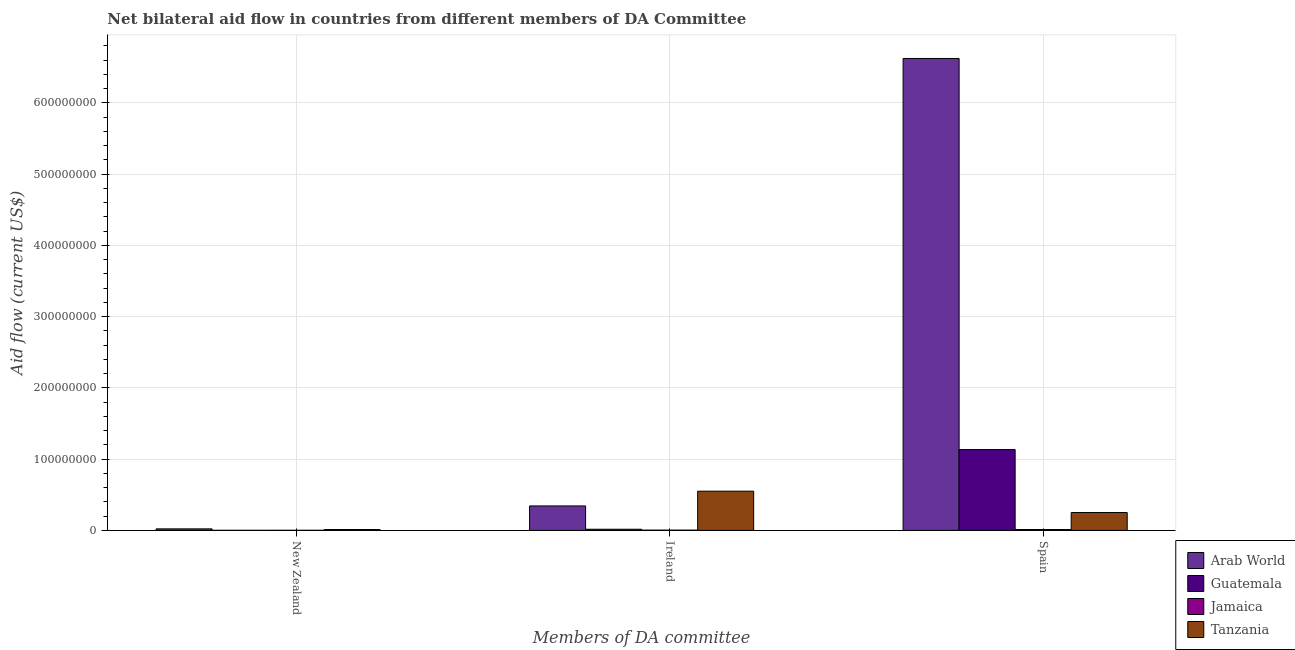Are the number of bars on each tick of the X-axis equal?
Provide a succinct answer. Yes. What is the label of the 1st group of bars from the left?
Keep it short and to the point. New Zealand. What is the amount of aid provided by ireland in Jamaica?
Provide a short and direct response. 3.50e+05. Across all countries, what is the maximum amount of aid provided by spain?
Your answer should be very brief. 6.62e+08. Across all countries, what is the minimum amount of aid provided by new zealand?
Ensure brevity in your answer.  8.00e+04. In which country was the amount of aid provided by new zealand maximum?
Your response must be concise. Arab World. In which country was the amount of aid provided by new zealand minimum?
Your answer should be compact. Guatemala. What is the total amount of aid provided by new zealand in the graph?
Your answer should be very brief. 3.55e+06. What is the difference between the amount of aid provided by ireland in Guatemala and that in Tanzania?
Give a very brief answer. -5.34e+07. What is the difference between the amount of aid provided by new zealand in Tanzania and the amount of aid provided by ireland in Guatemala?
Provide a succinct answer. -3.90e+05. What is the average amount of aid provided by spain per country?
Ensure brevity in your answer.  2.00e+08. What is the difference between the amount of aid provided by ireland and amount of aid provided by spain in Arab World?
Keep it short and to the point. -6.28e+08. In how many countries, is the amount of aid provided by ireland greater than 240000000 US$?
Your answer should be very brief. 0. What is the ratio of the amount of aid provided by spain in Arab World to that in Guatemala?
Provide a succinct answer. 5.84. What is the difference between the highest and the second highest amount of aid provided by spain?
Provide a succinct answer. 5.49e+08. What is the difference between the highest and the lowest amount of aid provided by ireland?
Your answer should be very brief. 5.47e+07. What does the 4th bar from the left in Spain represents?
Offer a terse response. Tanzania. What does the 4th bar from the right in Spain represents?
Your response must be concise. Arab World. How many bars are there?
Keep it short and to the point. 12. Are all the bars in the graph horizontal?
Ensure brevity in your answer.  No. How many countries are there in the graph?
Offer a terse response. 4. Are the values on the major ticks of Y-axis written in scientific E-notation?
Provide a succinct answer. No. Does the graph contain any zero values?
Offer a very short reply. No. Does the graph contain grids?
Your answer should be very brief. Yes. Where does the legend appear in the graph?
Your response must be concise. Bottom right. How many legend labels are there?
Your response must be concise. 4. What is the title of the graph?
Keep it short and to the point. Net bilateral aid flow in countries from different members of DA Committee. What is the label or title of the X-axis?
Ensure brevity in your answer.  Members of DA committee. What is the label or title of the Y-axis?
Your answer should be very brief. Aid flow (current US$). What is the Aid flow (current US$) of Arab World in New Zealand?
Make the answer very short. 2.14e+06. What is the Aid flow (current US$) in Guatemala in New Zealand?
Offer a very short reply. 8.00e+04. What is the Aid flow (current US$) in Tanzania in New Zealand?
Provide a short and direct response. 1.22e+06. What is the Aid flow (current US$) of Arab World in Ireland?
Ensure brevity in your answer.  3.43e+07. What is the Aid flow (current US$) of Guatemala in Ireland?
Provide a succinct answer. 1.61e+06. What is the Aid flow (current US$) in Tanzania in Ireland?
Offer a very short reply. 5.50e+07. What is the Aid flow (current US$) of Arab World in Spain?
Give a very brief answer. 6.62e+08. What is the Aid flow (current US$) of Guatemala in Spain?
Offer a terse response. 1.13e+08. What is the Aid flow (current US$) of Jamaica in Spain?
Ensure brevity in your answer.  1.19e+06. What is the Aid flow (current US$) of Tanzania in Spain?
Ensure brevity in your answer.  2.51e+07. Across all Members of DA committee, what is the maximum Aid flow (current US$) in Arab World?
Your answer should be compact. 6.62e+08. Across all Members of DA committee, what is the maximum Aid flow (current US$) in Guatemala?
Your answer should be very brief. 1.13e+08. Across all Members of DA committee, what is the maximum Aid flow (current US$) of Jamaica?
Your answer should be compact. 1.19e+06. Across all Members of DA committee, what is the maximum Aid flow (current US$) of Tanzania?
Make the answer very short. 5.50e+07. Across all Members of DA committee, what is the minimum Aid flow (current US$) in Arab World?
Give a very brief answer. 2.14e+06. Across all Members of DA committee, what is the minimum Aid flow (current US$) of Tanzania?
Offer a terse response. 1.22e+06. What is the total Aid flow (current US$) in Arab World in the graph?
Your response must be concise. 6.99e+08. What is the total Aid flow (current US$) of Guatemala in the graph?
Your response must be concise. 1.15e+08. What is the total Aid flow (current US$) in Jamaica in the graph?
Your answer should be compact. 1.65e+06. What is the total Aid flow (current US$) of Tanzania in the graph?
Provide a short and direct response. 8.13e+07. What is the difference between the Aid flow (current US$) of Arab World in New Zealand and that in Ireland?
Your answer should be compact. -3.22e+07. What is the difference between the Aid flow (current US$) in Guatemala in New Zealand and that in Ireland?
Your response must be concise. -1.53e+06. What is the difference between the Aid flow (current US$) of Jamaica in New Zealand and that in Ireland?
Keep it short and to the point. -2.40e+05. What is the difference between the Aid flow (current US$) of Tanzania in New Zealand and that in Ireland?
Provide a succinct answer. -5.38e+07. What is the difference between the Aid flow (current US$) of Arab World in New Zealand and that in Spain?
Keep it short and to the point. -6.60e+08. What is the difference between the Aid flow (current US$) in Guatemala in New Zealand and that in Spain?
Give a very brief answer. -1.13e+08. What is the difference between the Aid flow (current US$) in Jamaica in New Zealand and that in Spain?
Provide a short and direct response. -1.08e+06. What is the difference between the Aid flow (current US$) of Tanzania in New Zealand and that in Spain?
Offer a terse response. -2.39e+07. What is the difference between the Aid flow (current US$) in Arab World in Ireland and that in Spain?
Give a very brief answer. -6.28e+08. What is the difference between the Aid flow (current US$) in Guatemala in Ireland and that in Spain?
Make the answer very short. -1.12e+08. What is the difference between the Aid flow (current US$) in Jamaica in Ireland and that in Spain?
Your answer should be compact. -8.40e+05. What is the difference between the Aid flow (current US$) in Tanzania in Ireland and that in Spain?
Your answer should be compact. 3.00e+07. What is the difference between the Aid flow (current US$) in Arab World in New Zealand and the Aid flow (current US$) in Guatemala in Ireland?
Offer a terse response. 5.30e+05. What is the difference between the Aid flow (current US$) in Arab World in New Zealand and the Aid flow (current US$) in Jamaica in Ireland?
Your answer should be compact. 1.79e+06. What is the difference between the Aid flow (current US$) in Arab World in New Zealand and the Aid flow (current US$) in Tanzania in Ireland?
Ensure brevity in your answer.  -5.29e+07. What is the difference between the Aid flow (current US$) of Guatemala in New Zealand and the Aid flow (current US$) of Jamaica in Ireland?
Give a very brief answer. -2.70e+05. What is the difference between the Aid flow (current US$) in Guatemala in New Zealand and the Aid flow (current US$) in Tanzania in Ireland?
Offer a terse response. -5.50e+07. What is the difference between the Aid flow (current US$) in Jamaica in New Zealand and the Aid flow (current US$) in Tanzania in Ireland?
Your response must be concise. -5.49e+07. What is the difference between the Aid flow (current US$) in Arab World in New Zealand and the Aid flow (current US$) in Guatemala in Spain?
Your answer should be very brief. -1.11e+08. What is the difference between the Aid flow (current US$) in Arab World in New Zealand and the Aid flow (current US$) in Jamaica in Spain?
Your response must be concise. 9.50e+05. What is the difference between the Aid flow (current US$) in Arab World in New Zealand and the Aid flow (current US$) in Tanzania in Spain?
Ensure brevity in your answer.  -2.29e+07. What is the difference between the Aid flow (current US$) of Guatemala in New Zealand and the Aid flow (current US$) of Jamaica in Spain?
Your answer should be very brief. -1.11e+06. What is the difference between the Aid flow (current US$) in Guatemala in New Zealand and the Aid flow (current US$) in Tanzania in Spain?
Your answer should be very brief. -2.50e+07. What is the difference between the Aid flow (current US$) in Jamaica in New Zealand and the Aid flow (current US$) in Tanzania in Spain?
Provide a succinct answer. -2.50e+07. What is the difference between the Aid flow (current US$) of Arab World in Ireland and the Aid flow (current US$) of Guatemala in Spain?
Provide a succinct answer. -7.91e+07. What is the difference between the Aid flow (current US$) in Arab World in Ireland and the Aid flow (current US$) in Jamaica in Spain?
Your answer should be compact. 3.31e+07. What is the difference between the Aid flow (current US$) in Arab World in Ireland and the Aid flow (current US$) in Tanzania in Spain?
Your response must be concise. 9.25e+06. What is the difference between the Aid flow (current US$) of Guatemala in Ireland and the Aid flow (current US$) of Jamaica in Spain?
Ensure brevity in your answer.  4.20e+05. What is the difference between the Aid flow (current US$) of Guatemala in Ireland and the Aid flow (current US$) of Tanzania in Spain?
Provide a short and direct response. -2.35e+07. What is the difference between the Aid flow (current US$) in Jamaica in Ireland and the Aid flow (current US$) in Tanzania in Spain?
Make the answer very short. -2.47e+07. What is the average Aid flow (current US$) in Arab World per Members of DA committee?
Make the answer very short. 2.33e+08. What is the average Aid flow (current US$) in Guatemala per Members of DA committee?
Keep it short and to the point. 3.84e+07. What is the average Aid flow (current US$) of Tanzania per Members of DA committee?
Your response must be concise. 2.71e+07. What is the difference between the Aid flow (current US$) in Arab World and Aid flow (current US$) in Guatemala in New Zealand?
Your answer should be compact. 2.06e+06. What is the difference between the Aid flow (current US$) of Arab World and Aid flow (current US$) of Jamaica in New Zealand?
Your answer should be compact. 2.03e+06. What is the difference between the Aid flow (current US$) of Arab World and Aid flow (current US$) of Tanzania in New Zealand?
Your response must be concise. 9.20e+05. What is the difference between the Aid flow (current US$) in Guatemala and Aid flow (current US$) in Tanzania in New Zealand?
Your answer should be very brief. -1.14e+06. What is the difference between the Aid flow (current US$) in Jamaica and Aid flow (current US$) in Tanzania in New Zealand?
Provide a short and direct response. -1.11e+06. What is the difference between the Aid flow (current US$) in Arab World and Aid flow (current US$) in Guatemala in Ireland?
Your answer should be very brief. 3.27e+07. What is the difference between the Aid flow (current US$) of Arab World and Aid flow (current US$) of Jamaica in Ireland?
Your response must be concise. 3.40e+07. What is the difference between the Aid flow (current US$) in Arab World and Aid flow (current US$) in Tanzania in Ireland?
Offer a very short reply. -2.07e+07. What is the difference between the Aid flow (current US$) in Guatemala and Aid flow (current US$) in Jamaica in Ireland?
Your response must be concise. 1.26e+06. What is the difference between the Aid flow (current US$) in Guatemala and Aid flow (current US$) in Tanzania in Ireland?
Make the answer very short. -5.34e+07. What is the difference between the Aid flow (current US$) in Jamaica and Aid flow (current US$) in Tanzania in Ireland?
Offer a very short reply. -5.47e+07. What is the difference between the Aid flow (current US$) of Arab World and Aid flow (current US$) of Guatemala in Spain?
Ensure brevity in your answer.  5.49e+08. What is the difference between the Aid flow (current US$) of Arab World and Aid flow (current US$) of Jamaica in Spain?
Keep it short and to the point. 6.61e+08. What is the difference between the Aid flow (current US$) in Arab World and Aid flow (current US$) in Tanzania in Spain?
Give a very brief answer. 6.37e+08. What is the difference between the Aid flow (current US$) in Guatemala and Aid flow (current US$) in Jamaica in Spain?
Make the answer very short. 1.12e+08. What is the difference between the Aid flow (current US$) in Guatemala and Aid flow (current US$) in Tanzania in Spain?
Provide a succinct answer. 8.84e+07. What is the difference between the Aid flow (current US$) in Jamaica and Aid flow (current US$) in Tanzania in Spain?
Offer a terse response. -2.39e+07. What is the ratio of the Aid flow (current US$) of Arab World in New Zealand to that in Ireland?
Provide a succinct answer. 0.06. What is the ratio of the Aid flow (current US$) of Guatemala in New Zealand to that in Ireland?
Provide a short and direct response. 0.05. What is the ratio of the Aid flow (current US$) of Jamaica in New Zealand to that in Ireland?
Give a very brief answer. 0.31. What is the ratio of the Aid flow (current US$) of Tanzania in New Zealand to that in Ireland?
Your answer should be very brief. 0.02. What is the ratio of the Aid flow (current US$) in Arab World in New Zealand to that in Spain?
Keep it short and to the point. 0. What is the ratio of the Aid flow (current US$) in Guatemala in New Zealand to that in Spain?
Give a very brief answer. 0. What is the ratio of the Aid flow (current US$) in Jamaica in New Zealand to that in Spain?
Your response must be concise. 0.09. What is the ratio of the Aid flow (current US$) in Tanzania in New Zealand to that in Spain?
Give a very brief answer. 0.05. What is the ratio of the Aid flow (current US$) of Arab World in Ireland to that in Spain?
Your answer should be compact. 0.05. What is the ratio of the Aid flow (current US$) in Guatemala in Ireland to that in Spain?
Your answer should be very brief. 0.01. What is the ratio of the Aid flow (current US$) in Jamaica in Ireland to that in Spain?
Give a very brief answer. 0.29. What is the ratio of the Aid flow (current US$) of Tanzania in Ireland to that in Spain?
Offer a terse response. 2.19. What is the difference between the highest and the second highest Aid flow (current US$) of Arab World?
Make the answer very short. 6.28e+08. What is the difference between the highest and the second highest Aid flow (current US$) in Guatemala?
Provide a short and direct response. 1.12e+08. What is the difference between the highest and the second highest Aid flow (current US$) in Jamaica?
Your response must be concise. 8.40e+05. What is the difference between the highest and the second highest Aid flow (current US$) in Tanzania?
Offer a very short reply. 3.00e+07. What is the difference between the highest and the lowest Aid flow (current US$) in Arab World?
Provide a short and direct response. 6.60e+08. What is the difference between the highest and the lowest Aid flow (current US$) in Guatemala?
Offer a very short reply. 1.13e+08. What is the difference between the highest and the lowest Aid flow (current US$) of Jamaica?
Offer a terse response. 1.08e+06. What is the difference between the highest and the lowest Aid flow (current US$) in Tanzania?
Your answer should be compact. 5.38e+07. 